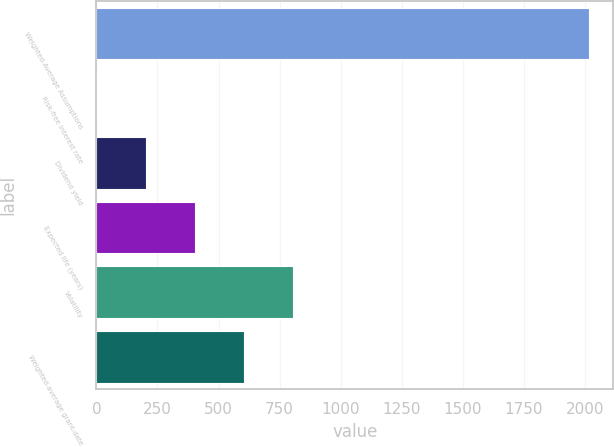<chart> <loc_0><loc_0><loc_500><loc_500><bar_chart><fcel>Weighted-Average Assumptions<fcel>Risk-free interest rate<fcel>Dividend yield<fcel>Expected life (years)<fcel>Volatility<fcel>Weighted-average grant-date<nl><fcel>2016<fcel>1.3<fcel>202.77<fcel>404.24<fcel>807.18<fcel>605.71<nl></chart> 